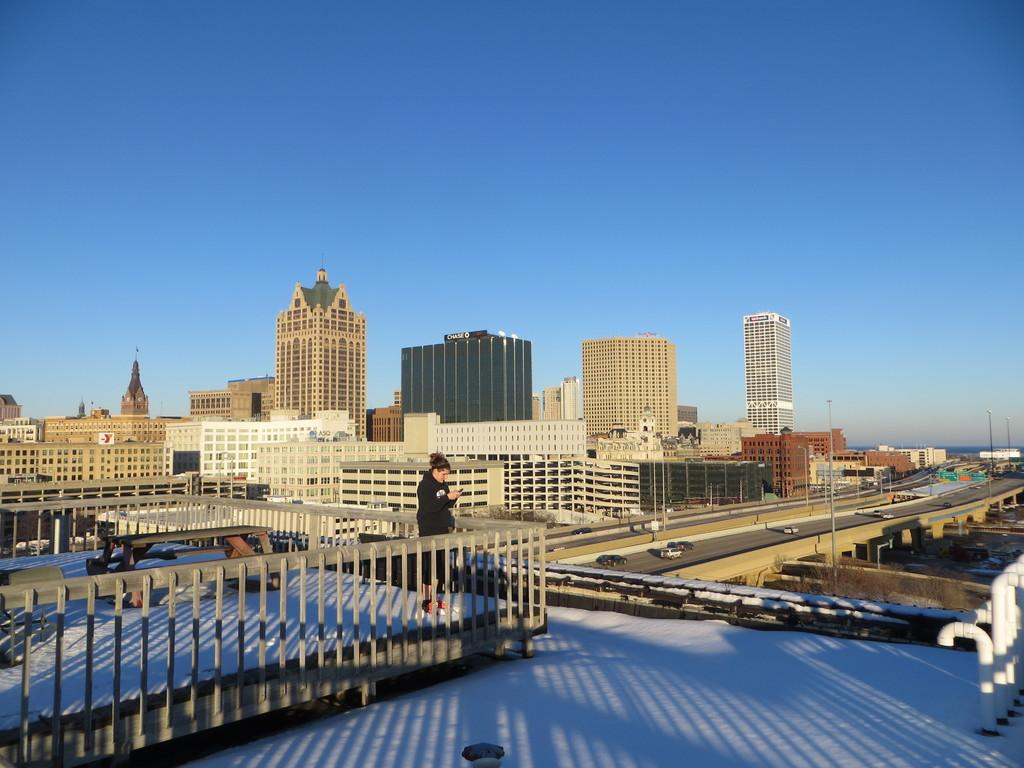What is the main subject of the image? There is a person standing in the image. What is the person standing near in the image? There is a bench in the image. What can be seen in the distance on the road in the image? There are vehicles on the road in the image. What type of structures are visible in the image? There are buildings in the image. What is visible in the background of the image? The sky is visible in the background of the image. What type of cord is being used to tie the balls together in the image? There are no balls or cords present in the image. How much butter is visible on the person's sandwich in the image? There is no sandwich or butter present in the image. 